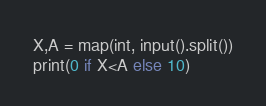Convert code to text. <code><loc_0><loc_0><loc_500><loc_500><_Python_>X,A = map(int, input().split())
print(0 if X<A else 10)</code> 